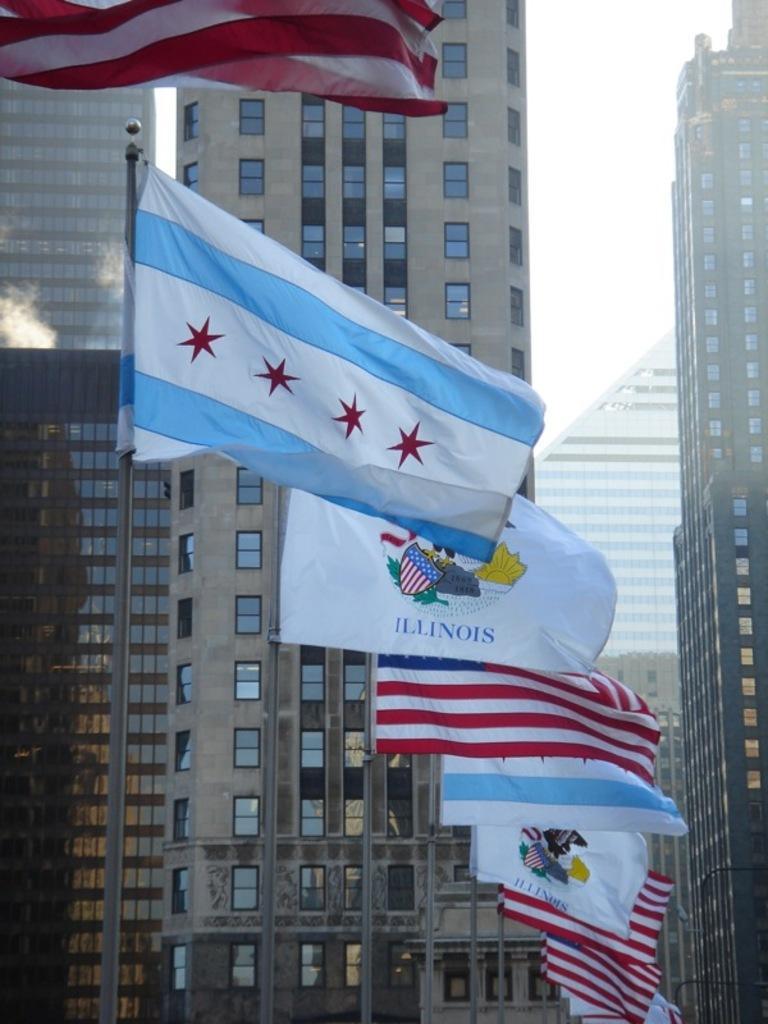Please provide a concise description of this image. In the image I can see some buildings and also I can see some flags to the poles. 